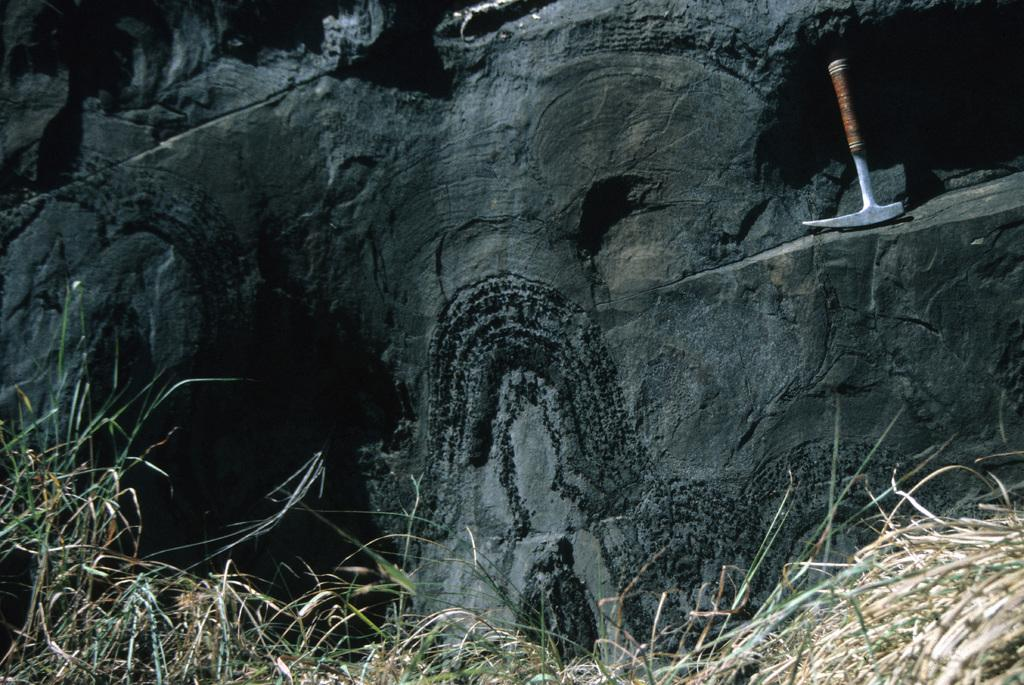What type of landscape is shown in the image? The image appears to depict a hill. What object can be seen on the right side of the image? There is an instrument on the right side of the image. What type of vegetation is present at the bottom of the image? Grass is present at the bottom of the image. What type of maid is visible in the image? There is no maid present in the image. What kind of lunch is being prepared on the hill in the image? There is no lunch preparation or any indication of food in the image. 